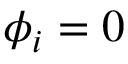Convert formula to latex. <formula><loc_0><loc_0><loc_500><loc_500>\phi _ { i } = 0</formula> 